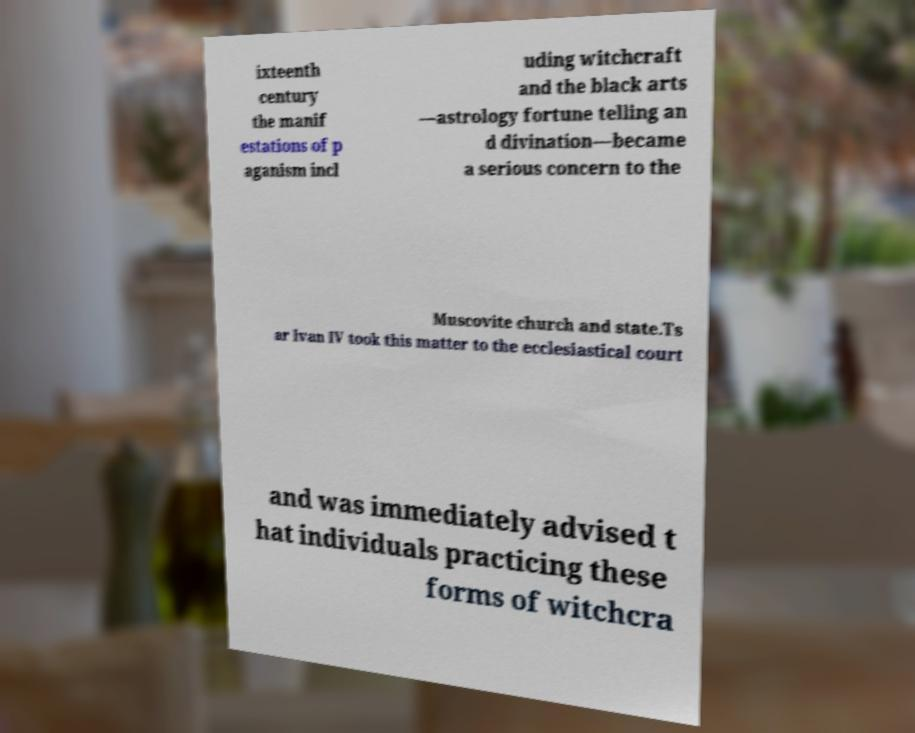I need the written content from this picture converted into text. Can you do that? ixteenth century the manif estations of p aganism incl uding witchcraft and the black arts —astrology fortune telling an d divination—became a serious concern to the Muscovite church and state.Ts ar Ivan IV took this matter to the ecclesiastical court and was immediately advised t hat individuals practicing these forms of witchcra 